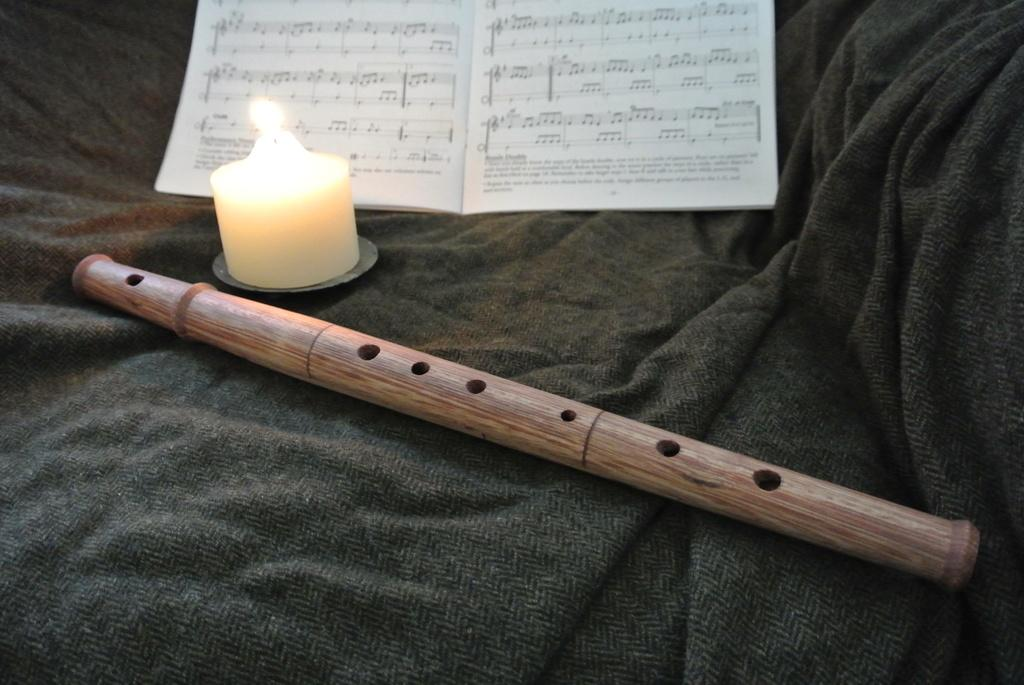What musical instrument is present in the image? There is a flute in the image. What other objects can be seen in the image? There is a candle and a book in the image. What is the color of the sheet or blanket at the bottom of the image? The sheet or blanket at the bottom of the image is black. How many pigs are shown giving their approval in the image? There are no pigs present in the image, nor is there any indication of approval being given. 